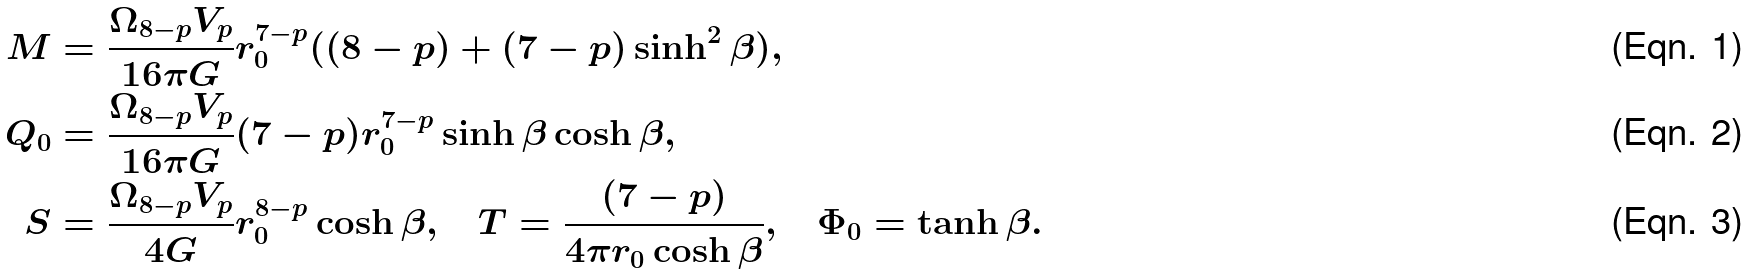Convert formula to latex. <formula><loc_0><loc_0><loc_500><loc_500>M & = \frac { \Omega _ { 8 - p } V _ { p } } { 1 6 \pi G } r _ { 0 } ^ { 7 - p } ( ( 8 - p ) + ( 7 - p ) \sinh ^ { 2 } \beta ) , \\ Q _ { 0 } & = \frac { \Omega _ { 8 - p } V _ { p } } { 1 6 \pi G } ( 7 - p ) r _ { 0 } ^ { 7 - p } \sinh \beta \cosh \beta , \\ S & = \frac { \Omega _ { 8 - p } V _ { p } } { 4 G } r _ { 0 } ^ { 8 - p } \cosh \beta , \quad T = \frac { ( 7 - p ) } { 4 \pi r _ { 0 } \cosh \beta } , \quad \Phi _ { 0 } = \tanh \beta .</formula> 